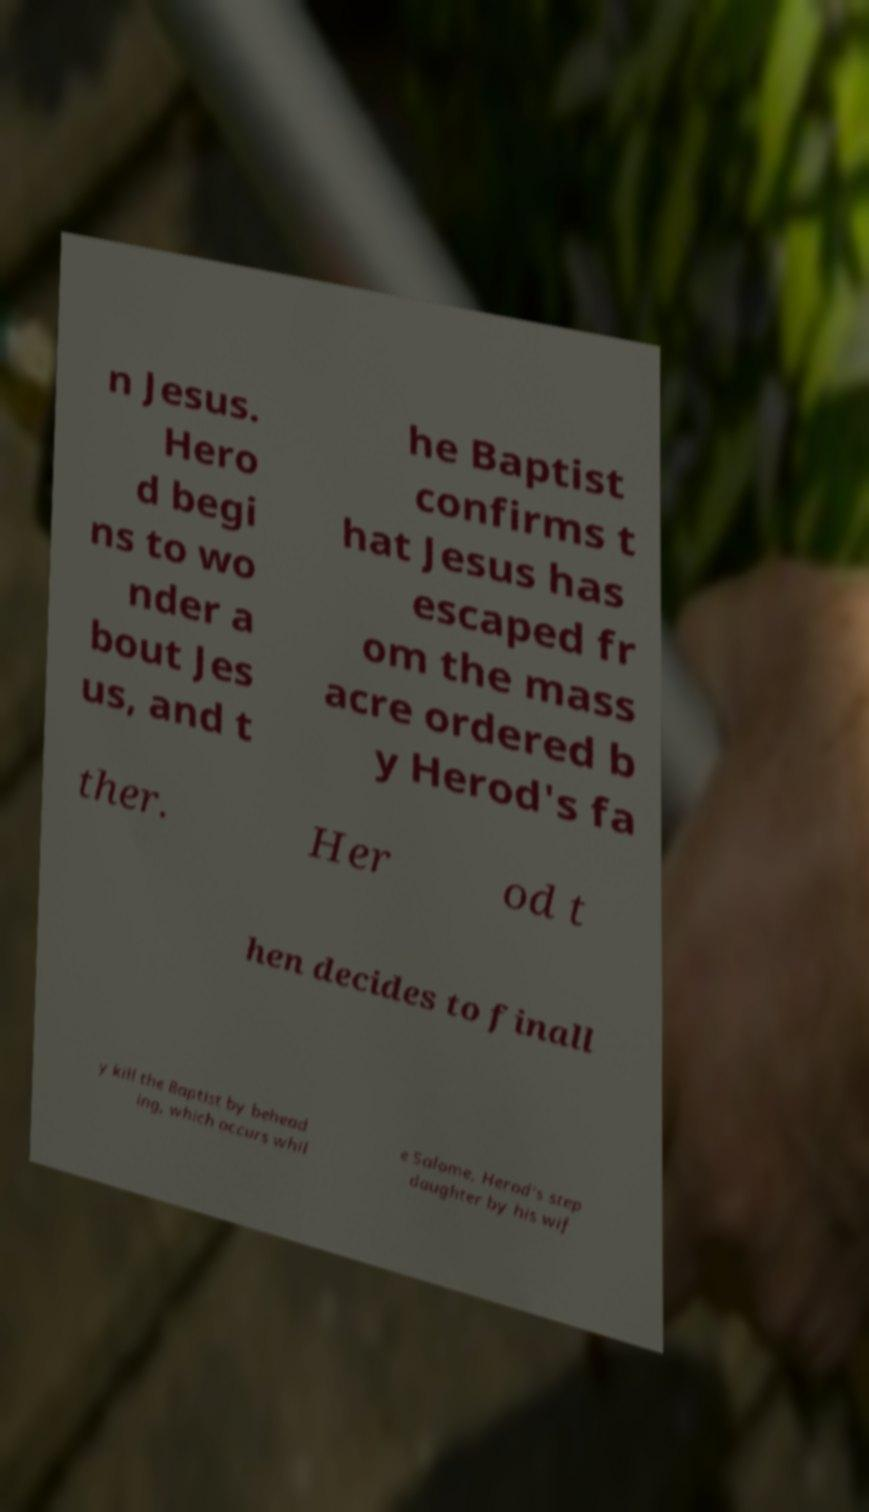Please read and relay the text visible in this image. What does it say? n Jesus. Hero d begi ns to wo nder a bout Jes us, and t he Baptist confirms t hat Jesus has escaped fr om the mass acre ordered b y Herod's fa ther. Her od t hen decides to finall y kill the Baptist by behead ing, which occurs whil e Salome, Herod's step daughter by his wif 